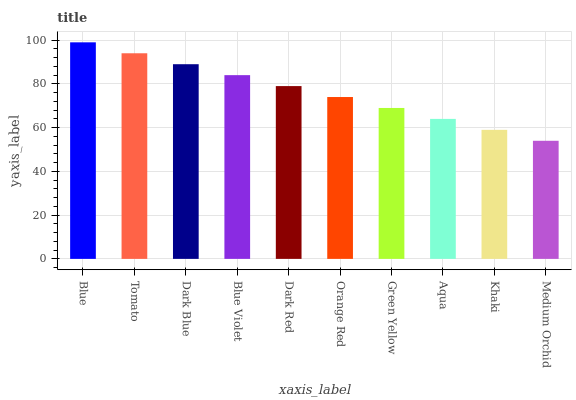Is Medium Orchid the minimum?
Answer yes or no. Yes. Is Blue the maximum?
Answer yes or no. Yes. Is Tomato the minimum?
Answer yes or no. No. Is Tomato the maximum?
Answer yes or no. No. Is Blue greater than Tomato?
Answer yes or no. Yes. Is Tomato less than Blue?
Answer yes or no. Yes. Is Tomato greater than Blue?
Answer yes or no. No. Is Blue less than Tomato?
Answer yes or no. No. Is Dark Red the high median?
Answer yes or no. Yes. Is Orange Red the low median?
Answer yes or no. Yes. Is Green Yellow the high median?
Answer yes or no. No. Is Dark Red the low median?
Answer yes or no. No. 